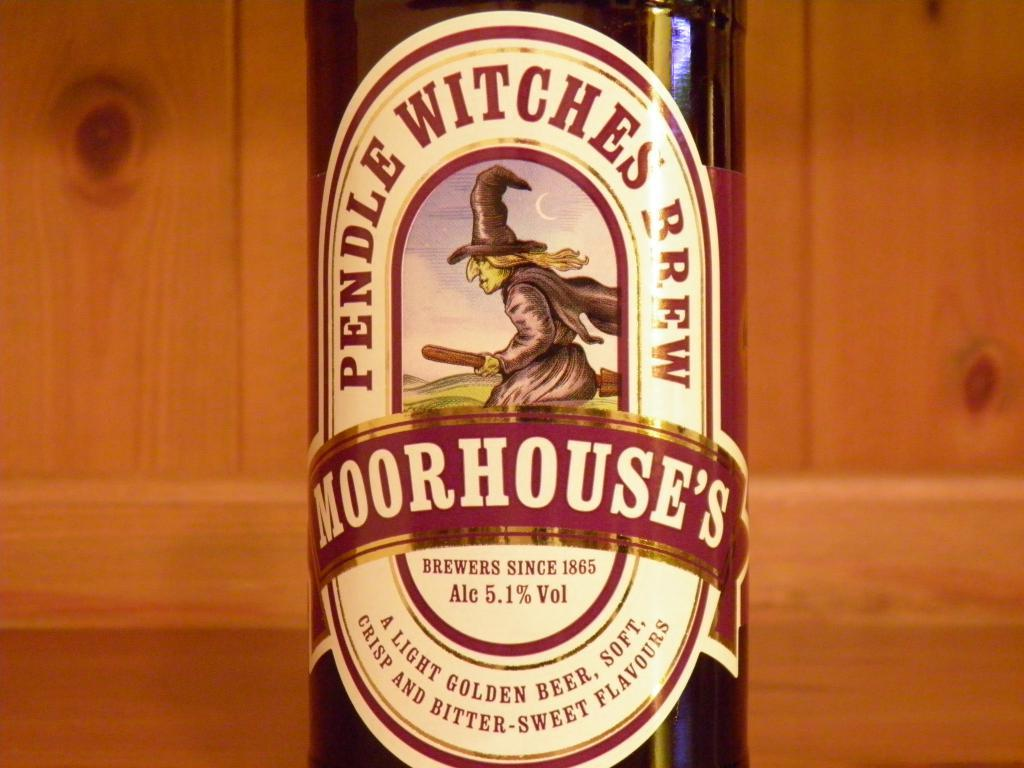<image>
Present a compact description of the photo's key features. Moorhouse's Pendle Witches Brew is the name of the label of this IPA. 